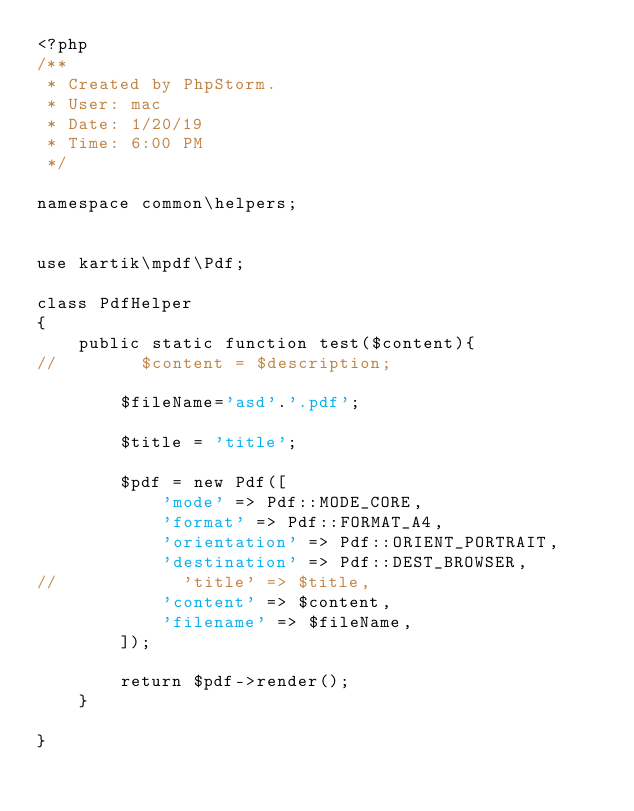Convert code to text. <code><loc_0><loc_0><loc_500><loc_500><_PHP_><?php
/**
 * Created by PhpStorm.
 * User: mac
 * Date: 1/20/19
 * Time: 6:00 PM
 */

namespace common\helpers;


use kartik\mpdf\Pdf;

class PdfHelper
{
    public static function test($content){
//        $content = $description;

        $fileName='asd'.'.pdf';

        $title = 'title';

        $pdf = new Pdf([
            'mode' => Pdf::MODE_CORE,
            'format' => Pdf::FORMAT_A4,
            'orientation' => Pdf::ORIENT_PORTRAIT,
            'destination' => Pdf::DEST_BROWSER,
//            'title' => $title,
            'content' => $content,
            'filename' => $fileName,
        ]);

        return $pdf->render();
    }

}</code> 